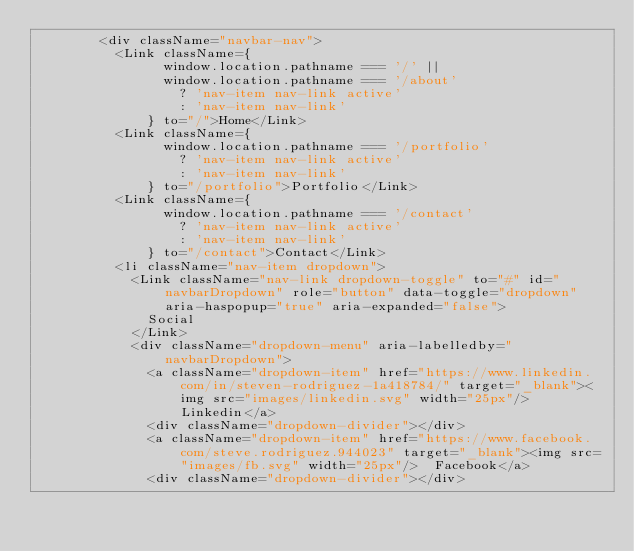<code> <loc_0><loc_0><loc_500><loc_500><_JavaScript_>        <div className="navbar-nav">
          <Link className={
                window.location.pathname === '/' ||
                window.location.pathname === '/about'
                  ? 'nav-item nav-link active'
                  : 'nav-item nav-link'
              } to="/">Home</Link>
          <Link className={
                window.location.pathname === '/portfolio'
                  ? 'nav-item nav-link active'
                  : 'nav-item nav-link'
              } to="/portfolio">Portfolio</Link>
          <Link className={
                window.location.pathname === '/contact'
                  ? 'nav-item nav-link active'
                  : 'nav-item nav-link'
              } to="/contact">Contact</Link>
          <li className="nav-item dropdown">
            <Link className="nav-link dropdown-toggle" to="#" id="navbarDropdown" role="button" data-toggle="dropdown" aria-haspopup="true" aria-expanded="false">
              Social
            </Link>
            <div className="dropdown-menu" aria-labelledby="navbarDropdown">
              <a className="dropdown-item" href="https://www.linkedin.com/in/steven-rodriguez-1a418784/" target="_blank"><img src="images/linkedin.svg" width="25px"/>  Linkedin</a>
              <div className="dropdown-divider"></div>
              <a className="dropdown-item" href="https://www.facebook.com/steve.rodriguez.944023" target="_blank"><img src="images/fb.svg" width="25px"/>  Facebook</a>
              <div className="dropdown-divider"></div></code> 